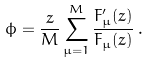<formula> <loc_0><loc_0><loc_500><loc_500>\phi = \frac { z } { M } \sum _ { \mu = 1 } ^ { M } \frac { F ^ { \prime } _ { \mu } ( z ) } { F _ { \mu } ( z ) } \, .</formula> 